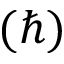Convert formula to latex. <formula><loc_0><loc_0><loc_500><loc_500>( \hbar { ) }</formula> 